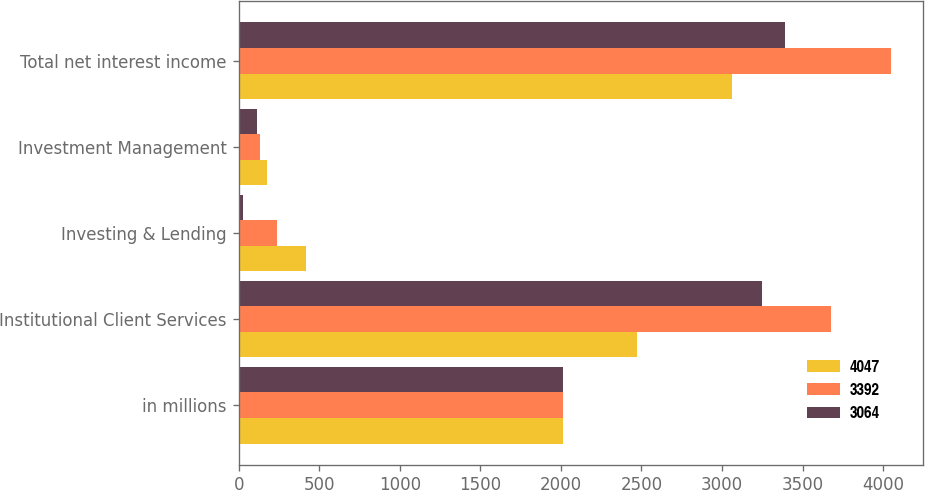<chart> <loc_0><loc_0><loc_500><loc_500><stacked_bar_chart><ecel><fcel>in millions<fcel>Institutional Client Services<fcel>Investing & Lending<fcel>Investment Management<fcel>Total net interest income<nl><fcel>4047<fcel>2015<fcel>2471<fcel>418<fcel>175<fcel>3064<nl><fcel>3392<fcel>2014<fcel>3679<fcel>237<fcel>131<fcel>4047<nl><fcel>3064<fcel>2013<fcel>3250<fcel>25<fcel>117<fcel>3392<nl></chart> 